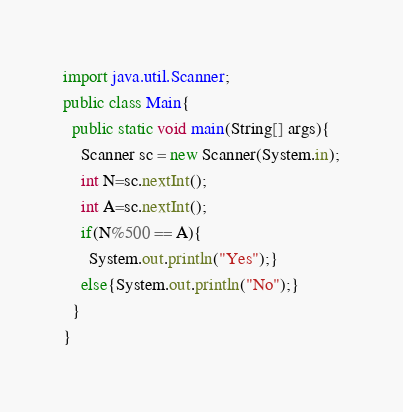Convert code to text. <code><loc_0><loc_0><loc_500><loc_500><_Java_>import java.util.Scanner;
public class Main{
  public static void main(String[] args){
    Scanner sc = new Scanner(System.in);
    int N=sc.nextInt();
    int A=sc.nextInt();
    if(N%500 == A){
      System.out.println("Yes");}
    else{System.out.println("No");}
  }
}
</code> 